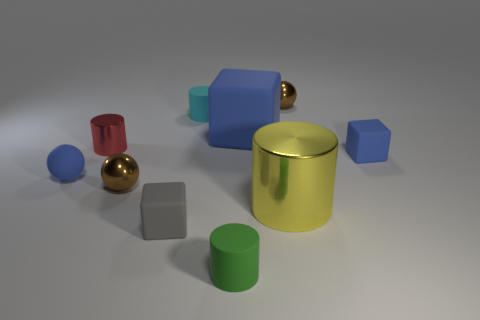What is the material of the tiny ball that is the same color as the big matte cube?
Your answer should be very brief. Rubber. Does the small gray rubber object have the same shape as the big blue object?
Provide a succinct answer. Yes. What number of blue blocks have the same material as the small gray block?
Provide a succinct answer. 2. There is a yellow object that is the same shape as the small cyan thing; what size is it?
Offer a very short reply. Large. Do the yellow thing and the cyan matte cylinder have the same size?
Offer a very short reply. No. What is the shape of the small brown object that is in front of the tiny ball that is behind the tiny rubber block on the right side of the large blue block?
Offer a very short reply. Sphere. The large thing that is the same shape as the tiny cyan object is what color?
Provide a short and direct response. Yellow. There is a thing that is both in front of the yellow cylinder and on the right side of the small gray block; what size is it?
Your response must be concise. Small. There is a tiny matte thing that is on the right side of the metal object that is behind the big blue object; what number of tiny green things are in front of it?
Your answer should be compact. 1. How many big objects are either rubber cylinders or brown spheres?
Offer a very short reply. 0. 